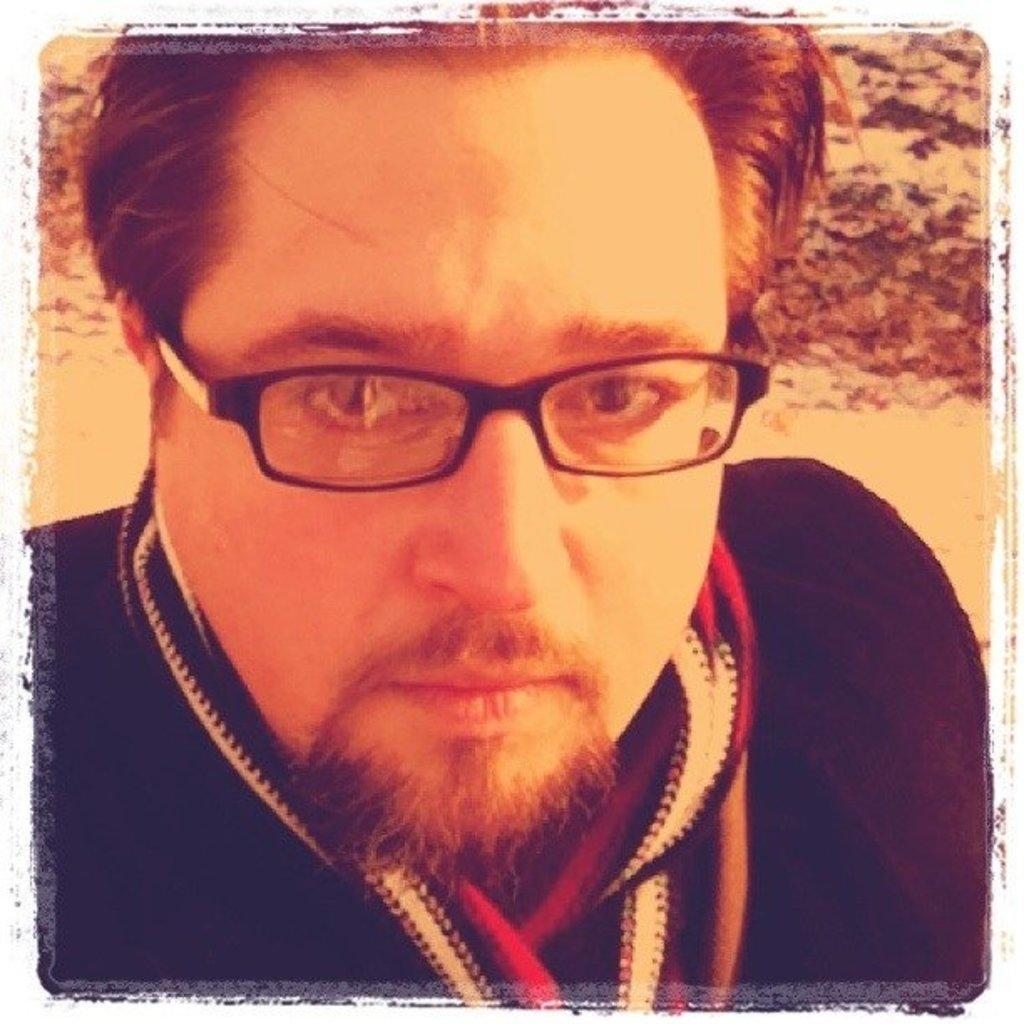How would you summarize this image in a sentence or two? In this image there is a man wearing spectacles. 